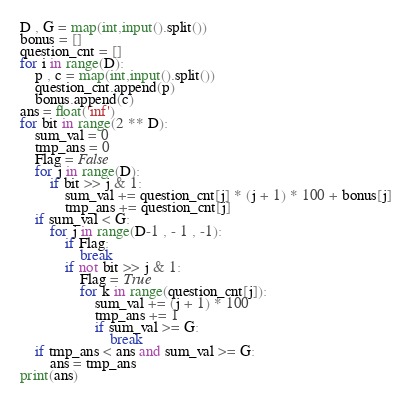<code> <loc_0><loc_0><loc_500><loc_500><_Python_>D , G = map(int,input().split())
bonus = []
question_cnt = []
for i in range(D):
    p , c = map(int,input().split())
    question_cnt.append(p)
    bonus.append(c)
ans = float('inf')
for bit in range(2 ** D):
    sum_val = 0
    tmp_ans = 0
    Flag = False
    for j in range(D):
        if bit >> j & 1:
            sum_val += question_cnt[j] * (j + 1) * 100 + bonus[j]
            tmp_ans += question_cnt[j]
    if sum_val < G:
        for j in range(D-1 , - 1 , -1):
            if Flag:
                break
            if not bit >> j & 1:
                Flag = True
                for k in range(question_cnt[j]):
                    sum_val += (j + 1) * 100
                    tmp_ans += 1
                    if sum_val >= G:
                        break
    if tmp_ans < ans and sum_val >= G:
        ans = tmp_ans
print(ans)
</code> 